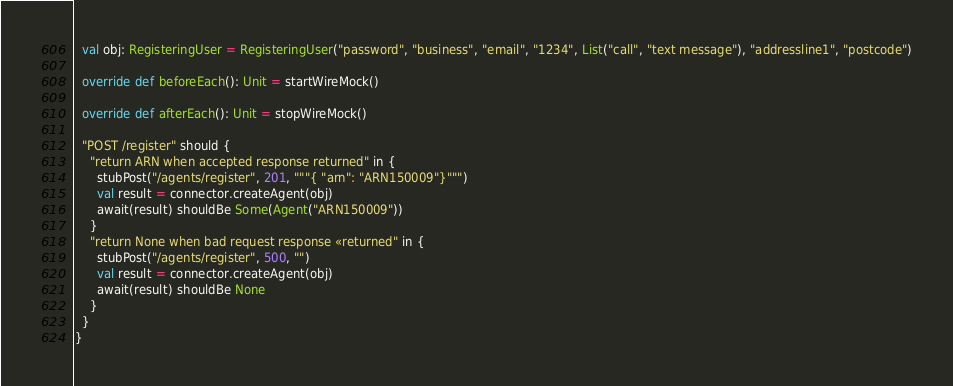Convert code to text. <code><loc_0><loc_0><loc_500><loc_500><_Scala_>  val obj: RegisteringUser = RegisteringUser("password", "business", "email", "1234", List("call", "text message"), "addressline1", "postcode")

  override def beforeEach(): Unit = startWireMock()

  override def afterEach(): Unit = stopWireMock()

  "POST /register" should {
    "return ARN when accepted response returned" in {
      stubPost("/agents/register", 201, """{ "arn": "ARN150009"}""")
      val result = connector.createAgent(obj)
      await(result) shouldBe Some(Agent("ARN150009"))
    }
    "return None when bad request response «returned" in {
      stubPost("/agents/register", 500, "")
      val result = connector.createAgent(obj)
      await(result) shouldBe None
    }
  }
}


</code> 